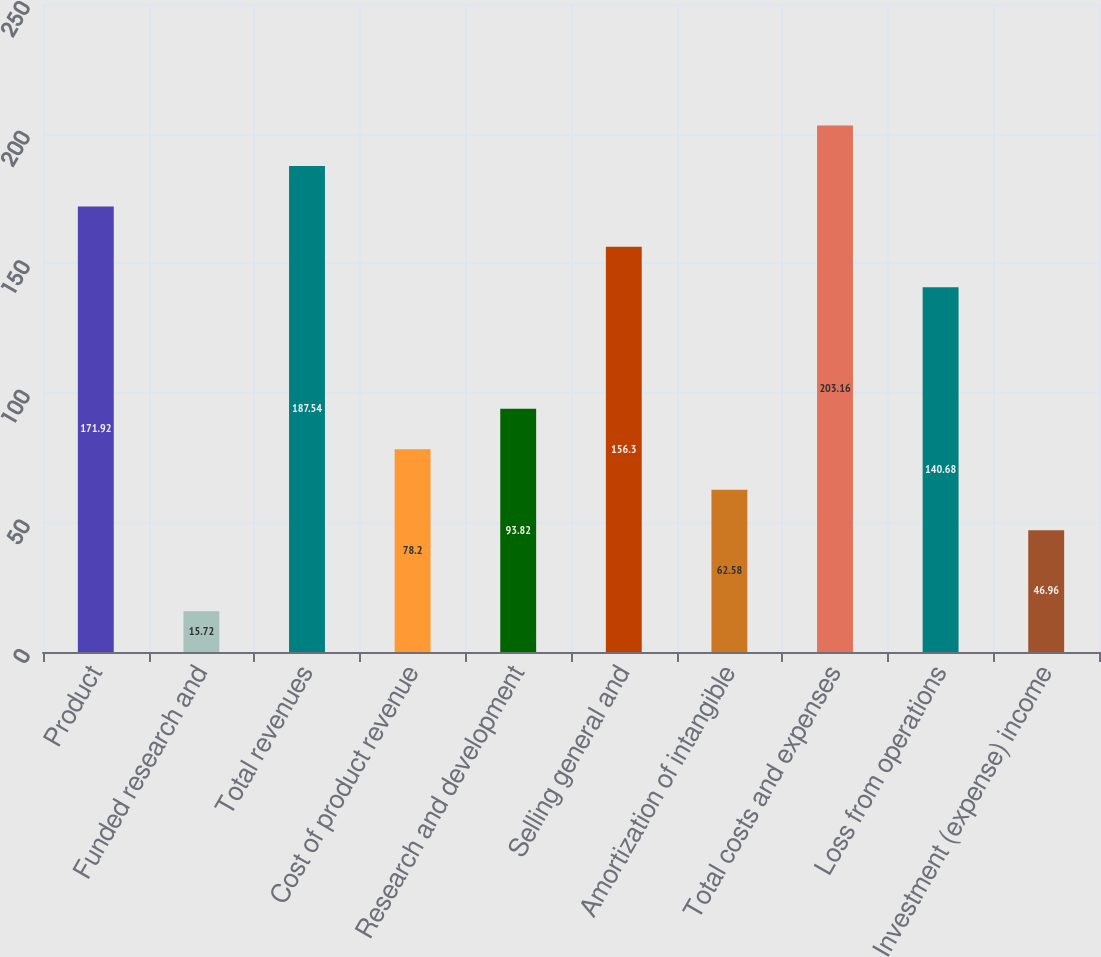Convert chart to OTSL. <chart><loc_0><loc_0><loc_500><loc_500><bar_chart><fcel>Product<fcel>Funded research and<fcel>Total revenues<fcel>Cost of product revenue<fcel>Research and development<fcel>Selling general and<fcel>Amortization of intangible<fcel>Total costs and expenses<fcel>Loss from operations<fcel>Investment (expense) income<nl><fcel>171.92<fcel>15.72<fcel>187.54<fcel>78.2<fcel>93.82<fcel>156.3<fcel>62.58<fcel>203.16<fcel>140.68<fcel>46.96<nl></chart> 